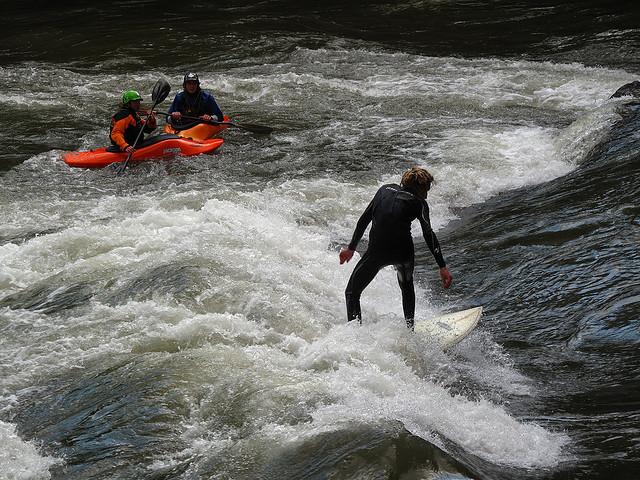How many people are in the water?
Give a very brief answer. 3. What are the rafters looking at?
Write a very short answer. Surfer. What color are the two boats behind the man?
Short answer required. Orange. 